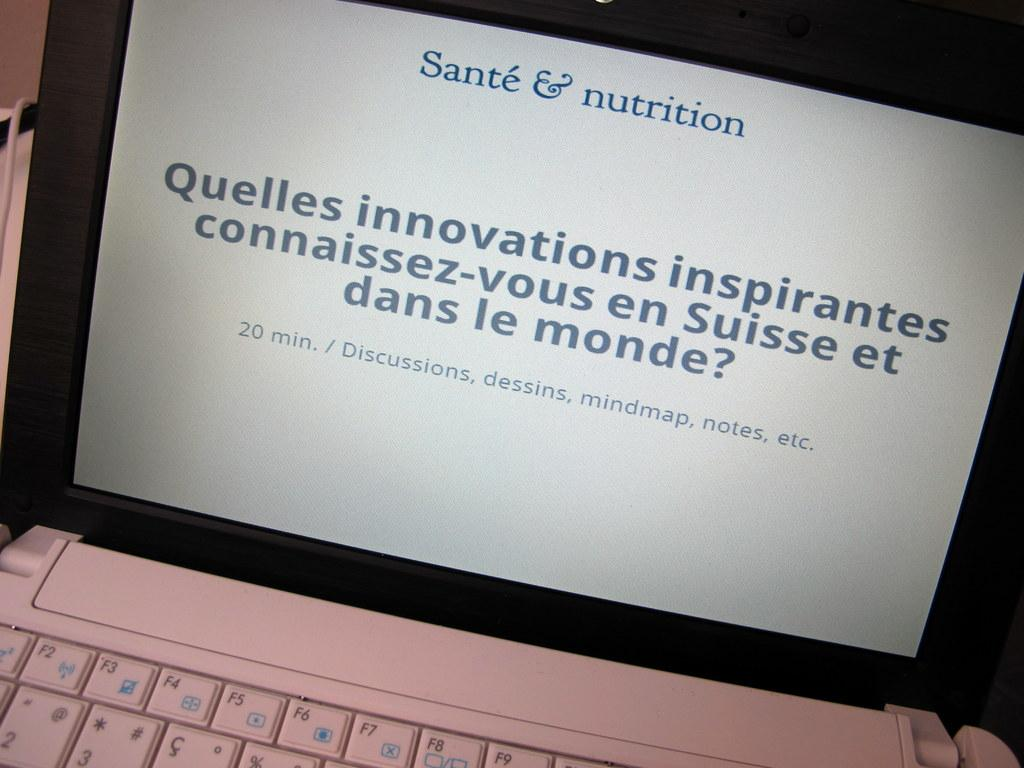<image>
Provide a brief description of the given image. A slide in French on a computer screen from Sante & nutrition 